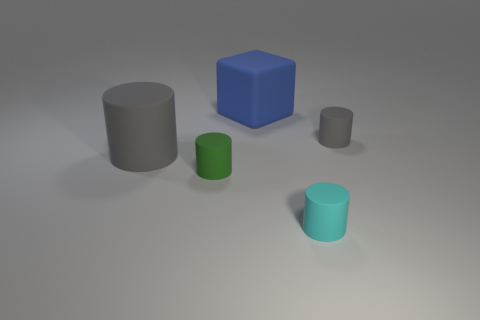Add 2 blue matte objects. How many objects exist? 7 Subtract all blocks. How many objects are left? 4 Subtract all matte cubes. Subtract all tiny green balls. How many objects are left? 4 Add 1 gray cylinders. How many gray cylinders are left? 3 Add 3 small green cylinders. How many small green cylinders exist? 4 Subtract 0 green blocks. How many objects are left? 5 